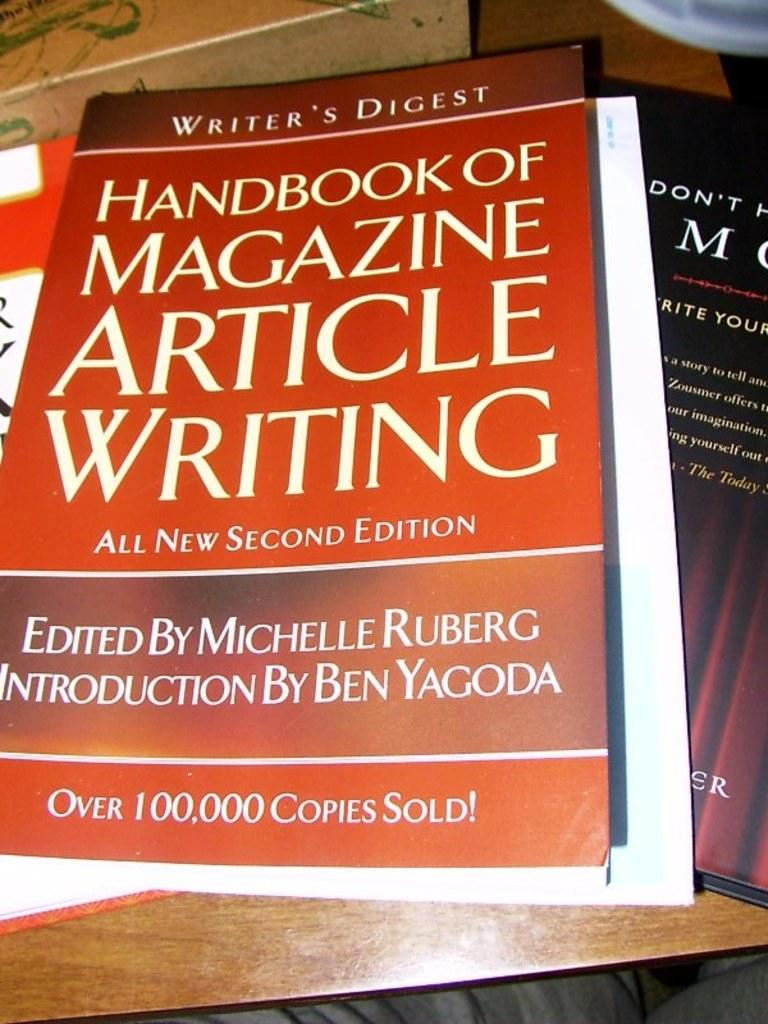<image>
Describe the image concisely. A handbook of magazine article writing with over 100,000 copies sold. 